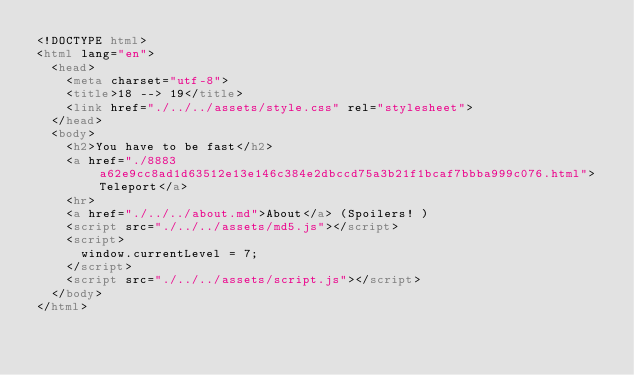<code> <loc_0><loc_0><loc_500><loc_500><_HTML_><!DOCTYPE html>
<html lang="en">
  <head>
    <meta charset="utf-8">
    <title>18 --> 19</title>
    <link href="./../../assets/style.css" rel="stylesheet">
  </head>
  <body>
    <h2>You have to be fast</h2>
    <a href="./8883a62e9cc8ad1d63512e13e146c384e2dbccd75a3b21f1bcaf7bbba999c076.html">Teleport</a>
    <hr>
    <a href="./../../about.md">About</a> (Spoilers! )
    <script src="./../../assets/md5.js"></script>
    <script>
      window.currentLevel = 7;
    </script>
    <script src="./../../assets/script.js"></script>
  </body>
</html></code> 